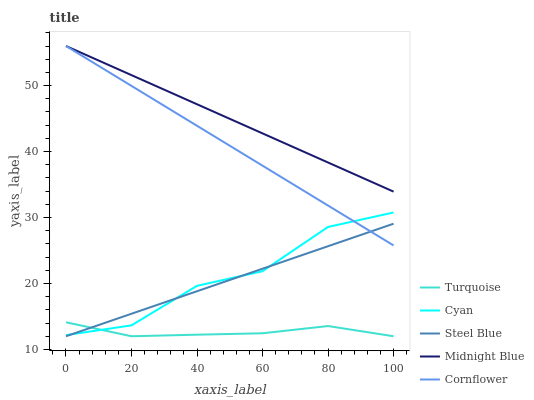Does Cornflower have the minimum area under the curve?
Answer yes or no. No. Does Cornflower have the maximum area under the curve?
Answer yes or no. No. Is Turquoise the smoothest?
Answer yes or no. No. Is Turquoise the roughest?
Answer yes or no. No. Does Cornflower have the lowest value?
Answer yes or no. No. Does Turquoise have the highest value?
Answer yes or no. No. Is Turquoise less than Midnight Blue?
Answer yes or no. Yes. Is Midnight Blue greater than Cyan?
Answer yes or no. Yes. Does Turquoise intersect Midnight Blue?
Answer yes or no. No. 